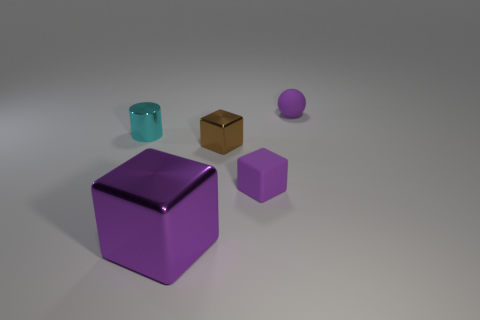There is a tiny purple object to the right of the tiny purple thing on the left side of the purple matte object that is behind the cyan cylinder; what is its material?
Provide a succinct answer. Rubber. There is a thing that is behind the brown thing and right of the cyan cylinder; what is its size?
Your answer should be very brief. Small. Is the shape of the cyan thing the same as the big thing?
Keep it short and to the point. No. The other big object that is made of the same material as the brown thing is what shape?
Your answer should be very brief. Cube. How many small objects are spheres or cyan shiny cylinders?
Give a very brief answer. 2. Are there any metallic things that are behind the tiny matte object in front of the metallic cylinder?
Provide a short and direct response. Yes. Is there a purple metallic block?
Make the answer very short. Yes. What is the color of the tiny metallic cylinder that is behind the purple block right of the large purple thing?
Give a very brief answer. Cyan. There is a small brown thing that is the same shape as the big shiny object; what material is it?
Your answer should be very brief. Metal. How many cyan things are the same size as the brown metal object?
Give a very brief answer. 1. 